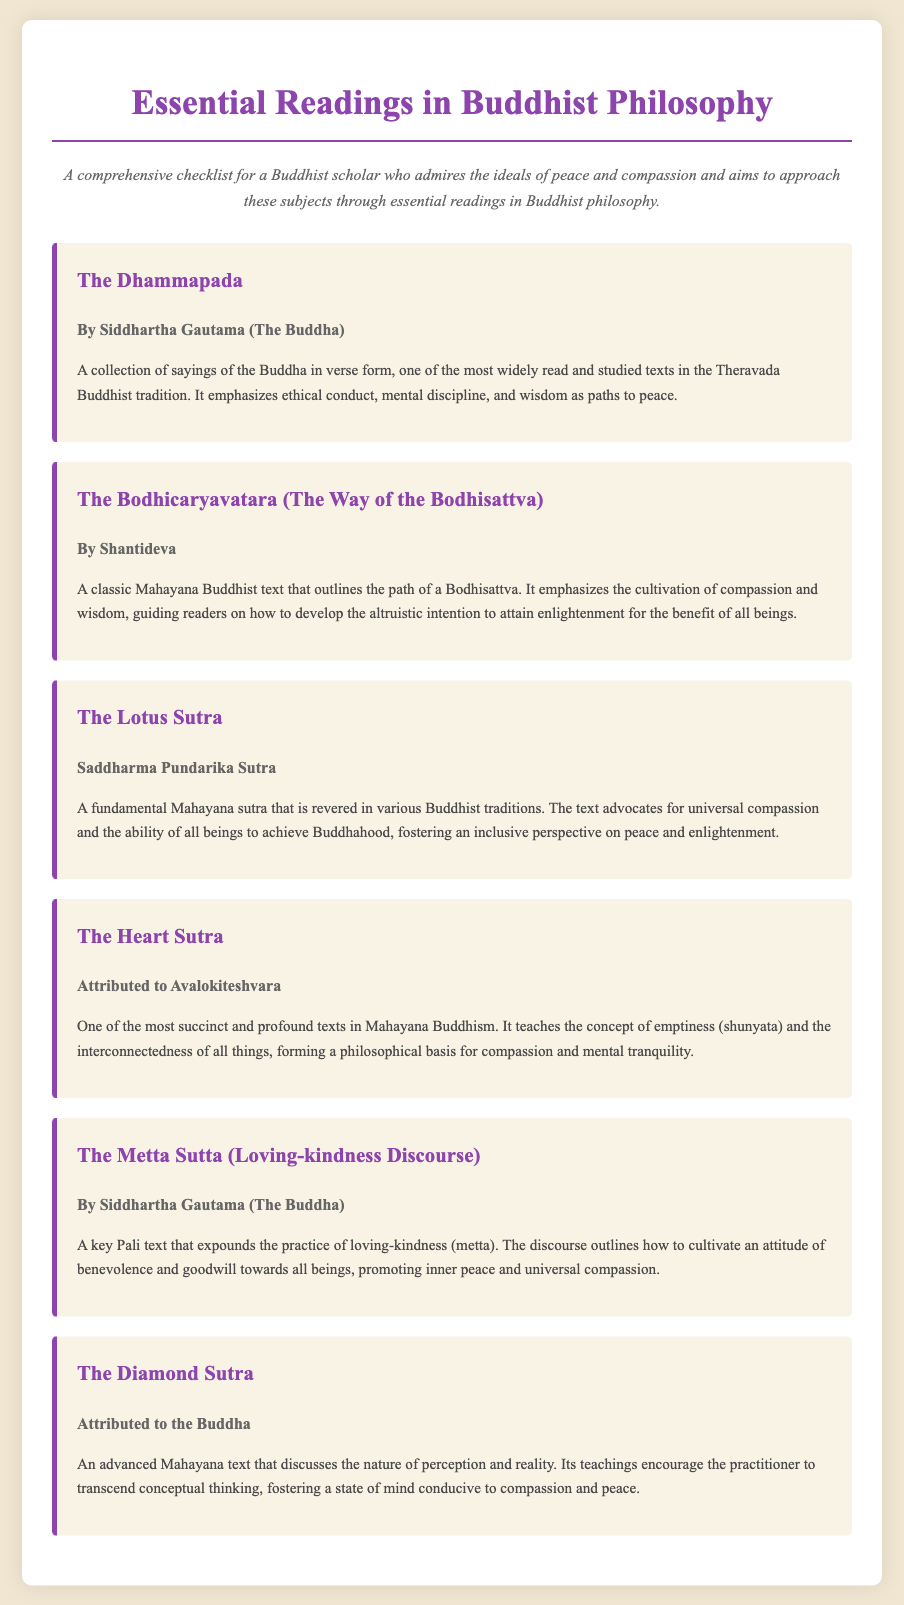What is the title of the first reading? The title of the first reading is listed at the top of its section in the checklist, which is "The Dhammapada."
Answer: The Dhammapada Who is the author of "The Bodhicaryavatara"? The author is mentioned directly under the title of "The Bodhicaryavatara," which is Shantideva.
Answer: Shantideva What is the main theme of "The Metta Sutta"? The main theme is summarized in the item description, focusing on cultivating loving-kindness (metta).
Answer: Loving-kindness How many essential readings are listed in the document? The total number of readings can be counted from the checklist provided, which lists six readings.
Answer: 6 Which text emphasizes the concept of emptiness? The document specifies that "The Heart Sutra" teaches the concept of emptiness, as detailed in its description.
Answer: The Heart Sutra What color is used for the titles of the checklist items? The color is described in the style section of the document, where it states that the color for titles is "#8E44AD."
Answer: #8E44AD Which reading is attributed to Avalokiteshvara? The checklist item specifically mentions that "The Heart Sutra" is attributed to Avalokiteshvara.
Answer: The Heart Sutra What is the overall purpose of this checklist? The purpose is stated in the introduction of the document, which aims to promote peace and compassion through essential readings in Buddhist philosophy.
Answer: Promote peace and compassion 